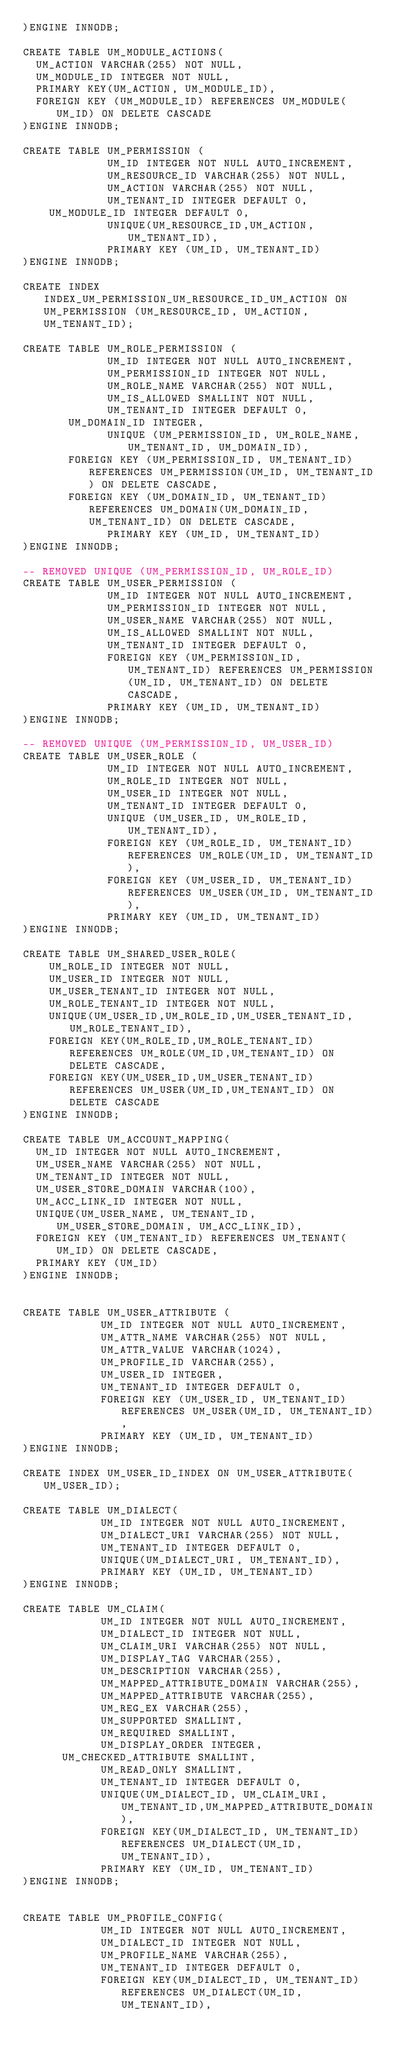<code> <loc_0><loc_0><loc_500><loc_500><_SQL_>)ENGINE INNODB;

CREATE TABLE UM_MODULE_ACTIONS(
	UM_ACTION VARCHAR(255) NOT NULL,
	UM_MODULE_ID INTEGER NOT NULL,
	PRIMARY KEY(UM_ACTION, UM_MODULE_ID),
	FOREIGN KEY (UM_MODULE_ID) REFERENCES UM_MODULE(UM_ID) ON DELETE CASCADE
)ENGINE INNODB;

CREATE TABLE UM_PERMISSION (
             UM_ID INTEGER NOT NULL AUTO_INCREMENT,
             UM_RESOURCE_ID VARCHAR(255) NOT NULL,
             UM_ACTION VARCHAR(255) NOT NULL,
             UM_TENANT_ID INTEGER DEFAULT 0,
		UM_MODULE_ID INTEGER DEFAULT 0,
			       UNIQUE(UM_RESOURCE_ID,UM_ACTION, UM_TENANT_ID),
             PRIMARY KEY (UM_ID, UM_TENANT_ID)
)ENGINE INNODB;

CREATE INDEX INDEX_UM_PERMISSION_UM_RESOURCE_ID_UM_ACTION ON UM_PERMISSION (UM_RESOURCE_ID, UM_ACTION, UM_TENANT_ID);

CREATE TABLE UM_ROLE_PERMISSION (
             UM_ID INTEGER NOT NULL AUTO_INCREMENT,
             UM_PERMISSION_ID INTEGER NOT NULL,
             UM_ROLE_NAME VARCHAR(255) NOT NULL,
             UM_IS_ALLOWED SMALLINT NOT NULL,
             UM_TENANT_ID INTEGER DEFAULT 0,
	     UM_DOMAIN_ID INTEGER,
             UNIQUE (UM_PERMISSION_ID, UM_ROLE_NAME, UM_TENANT_ID, UM_DOMAIN_ID),
	     FOREIGN KEY (UM_PERMISSION_ID, UM_TENANT_ID) REFERENCES UM_PERMISSION(UM_ID, UM_TENANT_ID) ON DELETE CASCADE,
	     FOREIGN KEY (UM_DOMAIN_ID, UM_TENANT_ID) REFERENCES UM_DOMAIN(UM_DOMAIN_ID, UM_TENANT_ID) ON DELETE CASCADE,
             PRIMARY KEY (UM_ID, UM_TENANT_ID)
)ENGINE INNODB;

-- REMOVED UNIQUE (UM_PERMISSION_ID, UM_ROLE_ID)
CREATE TABLE UM_USER_PERMISSION (
             UM_ID INTEGER NOT NULL AUTO_INCREMENT,
             UM_PERMISSION_ID INTEGER NOT NULL,
             UM_USER_NAME VARCHAR(255) NOT NULL,
             UM_IS_ALLOWED SMALLINT NOT NULL,
             UM_TENANT_ID INTEGER DEFAULT 0,
             FOREIGN KEY (UM_PERMISSION_ID, UM_TENANT_ID) REFERENCES UM_PERMISSION(UM_ID, UM_TENANT_ID) ON DELETE CASCADE,
             PRIMARY KEY (UM_ID, UM_TENANT_ID)
)ENGINE INNODB;

-- REMOVED UNIQUE (UM_PERMISSION_ID, UM_USER_ID)
CREATE TABLE UM_USER_ROLE (
             UM_ID INTEGER NOT NULL AUTO_INCREMENT,
             UM_ROLE_ID INTEGER NOT NULL,
             UM_USER_ID INTEGER NOT NULL,
             UM_TENANT_ID INTEGER DEFAULT 0,
             UNIQUE (UM_USER_ID, UM_ROLE_ID, UM_TENANT_ID),
             FOREIGN KEY (UM_ROLE_ID, UM_TENANT_ID) REFERENCES UM_ROLE(UM_ID, UM_TENANT_ID),
             FOREIGN KEY (UM_USER_ID, UM_TENANT_ID) REFERENCES UM_USER(UM_ID, UM_TENANT_ID),
             PRIMARY KEY (UM_ID, UM_TENANT_ID)
)ENGINE INNODB;

CREATE TABLE UM_SHARED_USER_ROLE(
    UM_ROLE_ID INTEGER NOT NULL,
    UM_USER_ID INTEGER NOT NULL,
    UM_USER_TENANT_ID INTEGER NOT NULL,
    UM_ROLE_TENANT_ID INTEGER NOT NULL,
    UNIQUE(UM_USER_ID,UM_ROLE_ID,UM_USER_TENANT_ID, UM_ROLE_TENANT_ID),
    FOREIGN KEY(UM_ROLE_ID,UM_ROLE_TENANT_ID) REFERENCES UM_ROLE(UM_ID,UM_TENANT_ID) ON DELETE CASCADE,
    FOREIGN KEY(UM_USER_ID,UM_USER_TENANT_ID) REFERENCES UM_USER(UM_ID,UM_TENANT_ID) ON DELETE CASCADE
)ENGINE INNODB;

CREATE TABLE UM_ACCOUNT_MAPPING(
	UM_ID INTEGER NOT NULL AUTO_INCREMENT,
	UM_USER_NAME VARCHAR(255) NOT NULL,
	UM_TENANT_ID INTEGER NOT NULL,
	UM_USER_STORE_DOMAIN VARCHAR(100),
	UM_ACC_LINK_ID INTEGER NOT NULL,
	UNIQUE(UM_USER_NAME, UM_TENANT_ID, UM_USER_STORE_DOMAIN, UM_ACC_LINK_ID),
	FOREIGN KEY (UM_TENANT_ID) REFERENCES UM_TENANT(UM_ID) ON DELETE CASCADE,
	PRIMARY KEY (UM_ID)
)ENGINE INNODB;


CREATE TABLE UM_USER_ATTRIBUTE (
            UM_ID INTEGER NOT NULL AUTO_INCREMENT,
            UM_ATTR_NAME VARCHAR(255) NOT NULL,
            UM_ATTR_VALUE VARCHAR(1024),
            UM_PROFILE_ID VARCHAR(255),
            UM_USER_ID INTEGER,
            UM_TENANT_ID INTEGER DEFAULT 0,
            FOREIGN KEY (UM_USER_ID, UM_TENANT_ID) REFERENCES UM_USER(UM_ID, UM_TENANT_ID),
            PRIMARY KEY (UM_ID, UM_TENANT_ID)
)ENGINE INNODB;

CREATE INDEX UM_USER_ID_INDEX ON UM_USER_ATTRIBUTE(UM_USER_ID);

CREATE TABLE UM_DIALECT(
            UM_ID INTEGER NOT NULL AUTO_INCREMENT,
            UM_DIALECT_URI VARCHAR(255) NOT NULL,
            UM_TENANT_ID INTEGER DEFAULT 0,
            UNIQUE(UM_DIALECT_URI, UM_TENANT_ID),
            PRIMARY KEY (UM_ID, UM_TENANT_ID)
)ENGINE INNODB;

CREATE TABLE UM_CLAIM(
            UM_ID INTEGER NOT NULL AUTO_INCREMENT,
            UM_DIALECT_ID INTEGER NOT NULL,
            UM_CLAIM_URI VARCHAR(255) NOT NULL,
            UM_DISPLAY_TAG VARCHAR(255),
            UM_DESCRIPTION VARCHAR(255),
            UM_MAPPED_ATTRIBUTE_DOMAIN VARCHAR(255),
            UM_MAPPED_ATTRIBUTE VARCHAR(255),
            UM_REG_EX VARCHAR(255),
            UM_SUPPORTED SMALLINT,
            UM_REQUIRED SMALLINT,
            UM_DISPLAY_ORDER INTEGER,
	    UM_CHECKED_ATTRIBUTE SMALLINT,
            UM_READ_ONLY SMALLINT,
            UM_TENANT_ID INTEGER DEFAULT 0,
            UNIQUE(UM_DIALECT_ID, UM_CLAIM_URI, UM_TENANT_ID,UM_MAPPED_ATTRIBUTE_DOMAIN),
            FOREIGN KEY(UM_DIALECT_ID, UM_TENANT_ID) REFERENCES UM_DIALECT(UM_ID, UM_TENANT_ID),
            PRIMARY KEY (UM_ID, UM_TENANT_ID)
)ENGINE INNODB;


CREATE TABLE UM_PROFILE_CONFIG(
            UM_ID INTEGER NOT NULL AUTO_INCREMENT,
            UM_DIALECT_ID INTEGER NOT NULL,
            UM_PROFILE_NAME VARCHAR(255),
            UM_TENANT_ID INTEGER DEFAULT 0,
            FOREIGN KEY(UM_DIALECT_ID, UM_TENANT_ID) REFERENCES UM_DIALECT(UM_ID, UM_TENANT_ID),</code> 